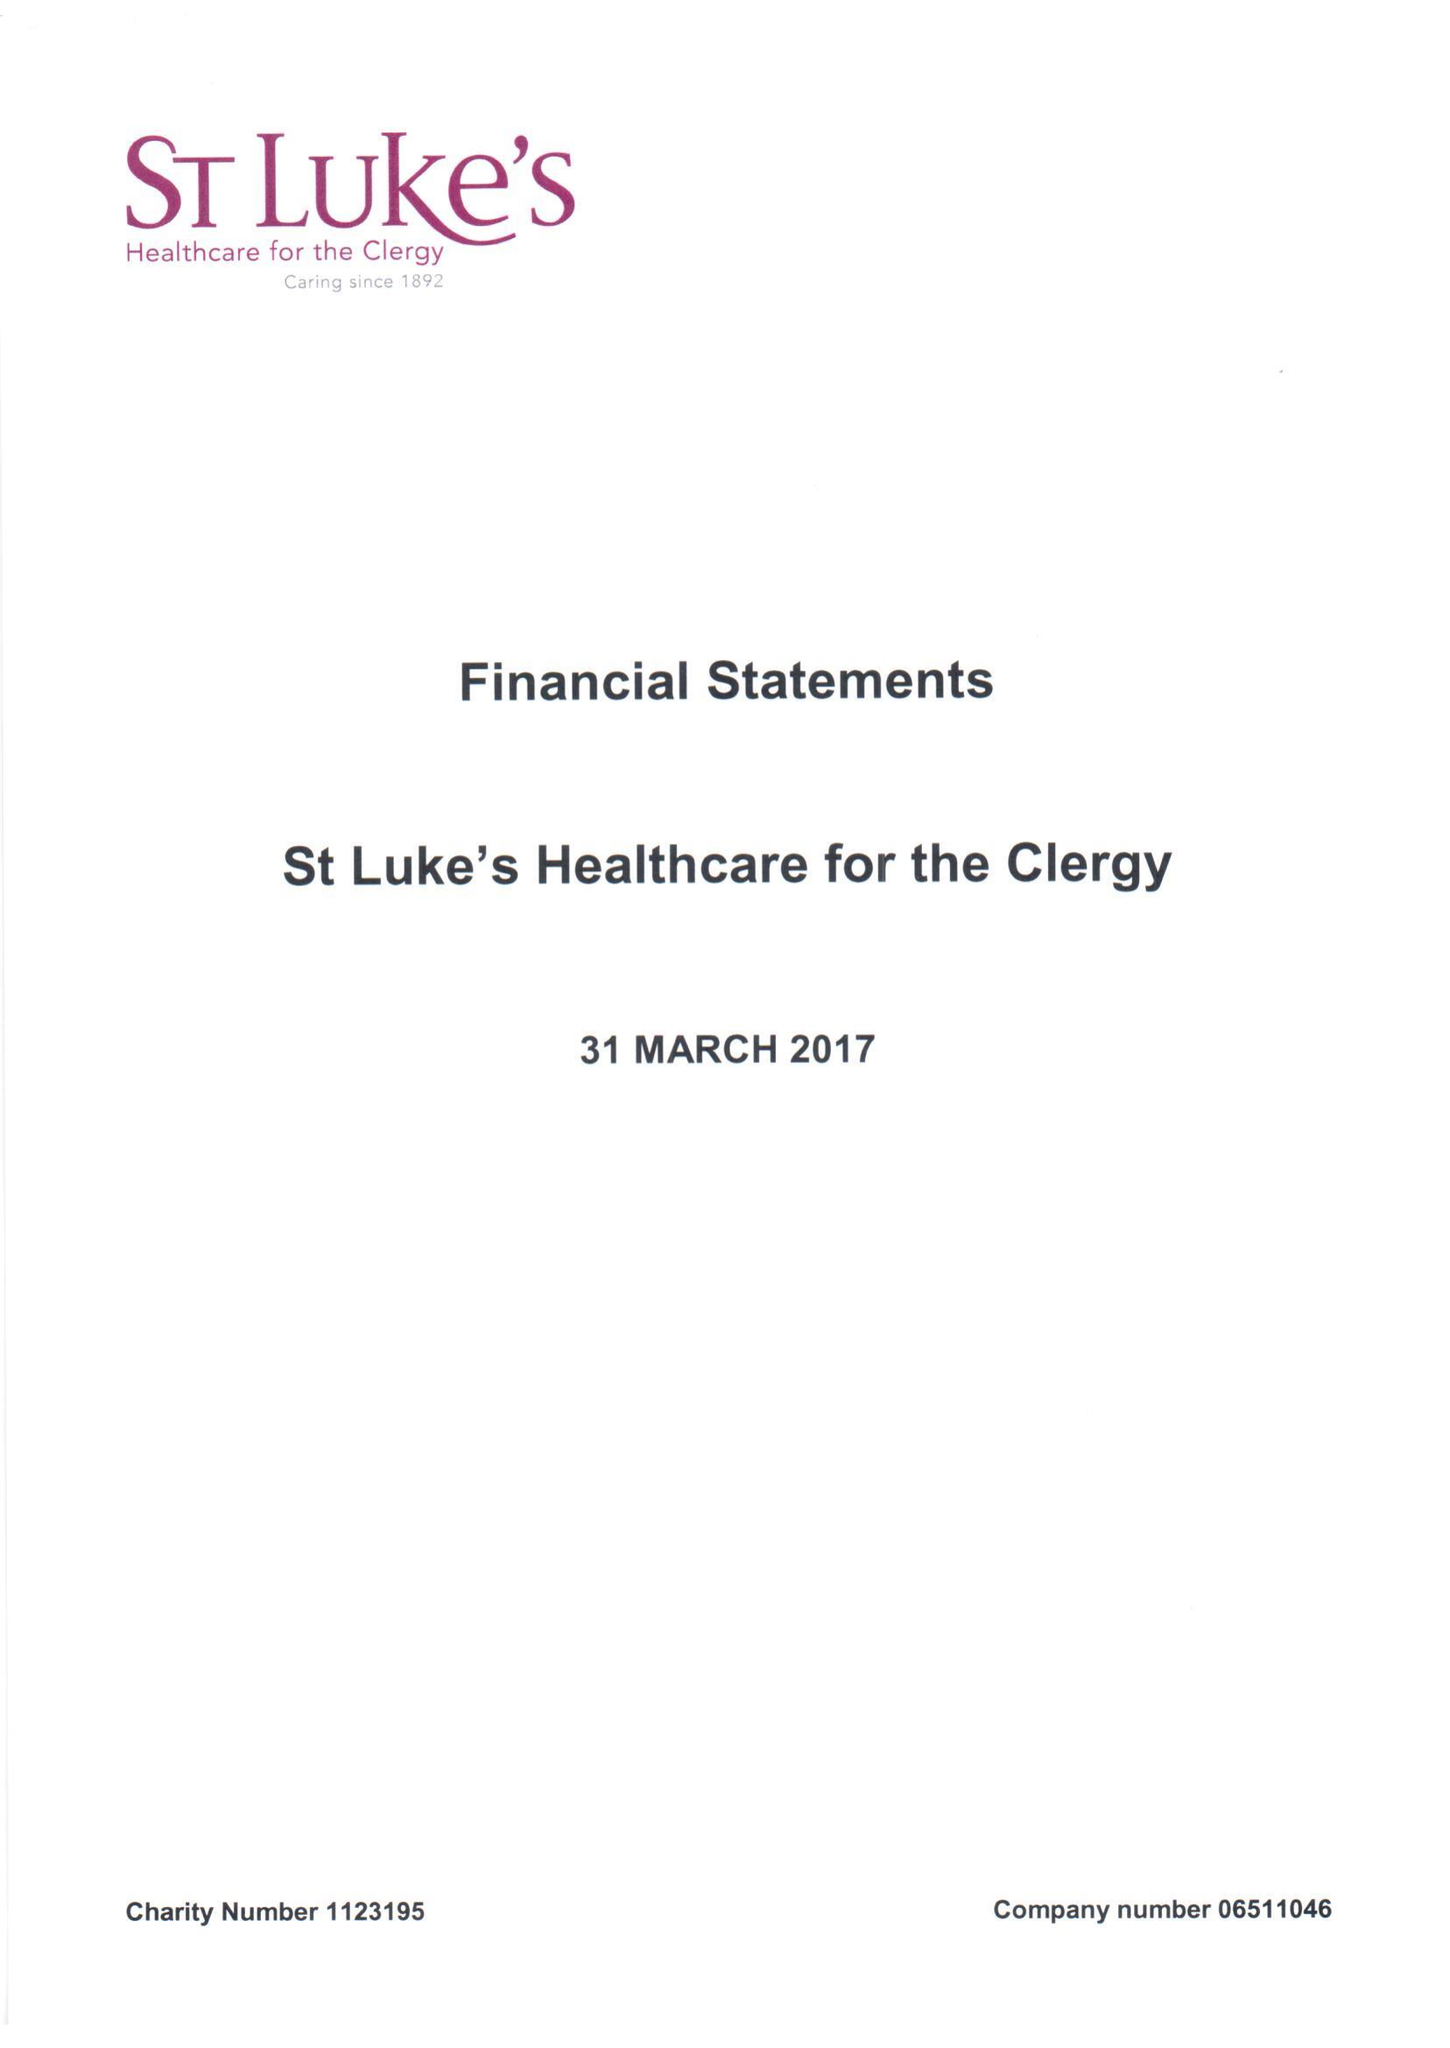What is the value for the spending_annually_in_british_pounds?
Answer the question using a single word or phrase. 592879.00 